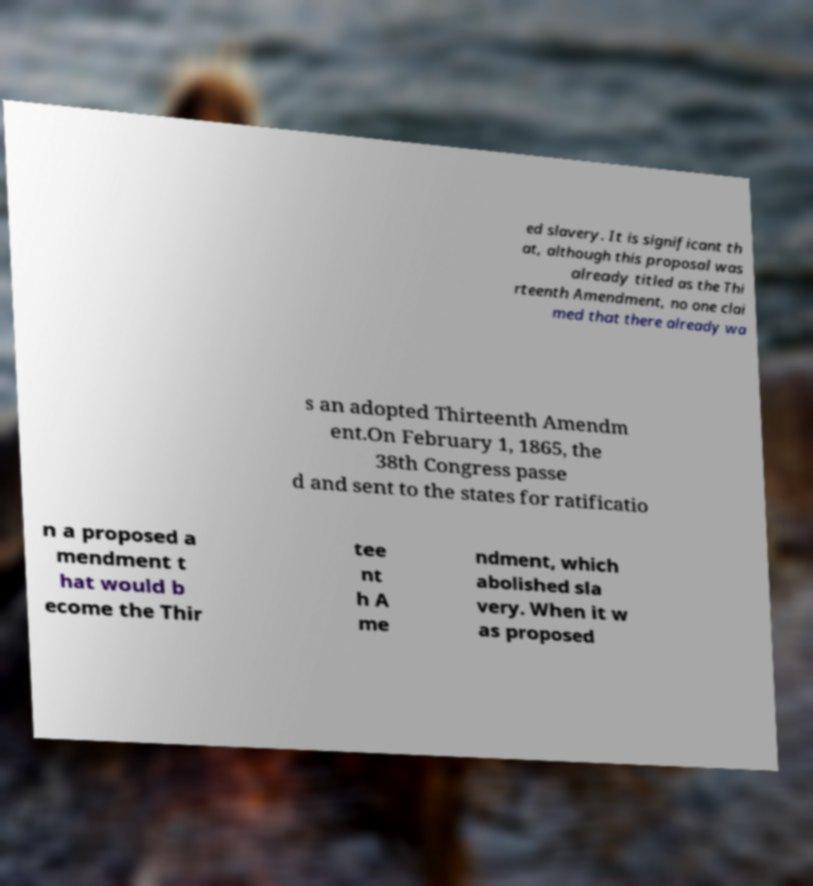What messages or text are displayed in this image? I need them in a readable, typed format. ed slavery. It is significant th at, although this proposal was already titled as the Thi rteenth Amendment, no one clai med that there already wa s an adopted Thirteenth Amendm ent.On February 1, 1865, the 38th Congress passe d and sent to the states for ratificatio n a proposed a mendment t hat would b ecome the Thir tee nt h A me ndment, which abolished sla very. When it w as proposed 